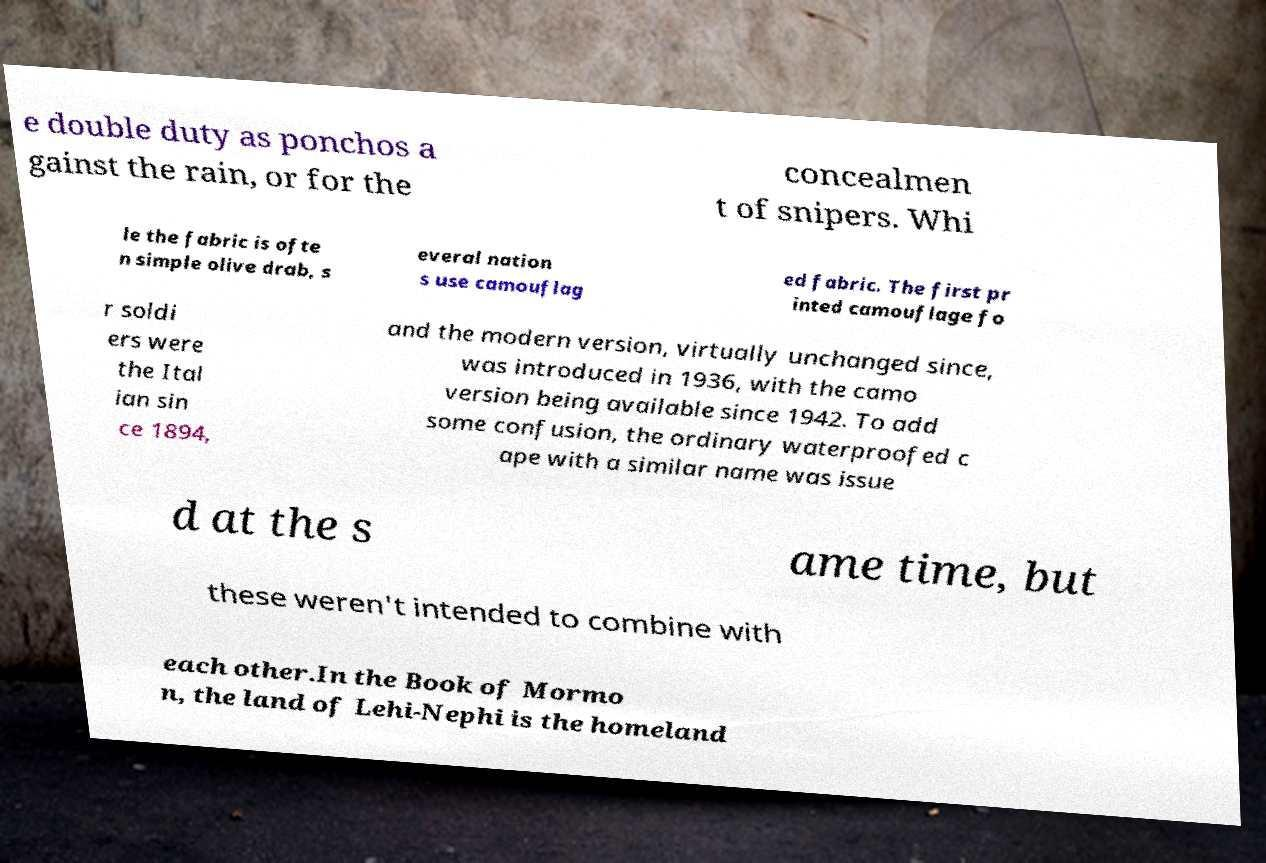Could you extract and type out the text from this image? e double duty as ponchos a gainst the rain, or for the concealmen t of snipers. Whi le the fabric is ofte n simple olive drab, s everal nation s use camouflag ed fabric. The first pr inted camouflage fo r soldi ers were the Ital ian sin ce 1894, and the modern version, virtually unchanged since, was introduced in 1936, with the camo version being available since 1942. To add some confusion, the ordinary waterproofed c ape with a similar name was issue d at the s ame time, but these weren't intended to combine with each other.In the Book of Mormo n, the land of Lehi-Nephi is the homeland 